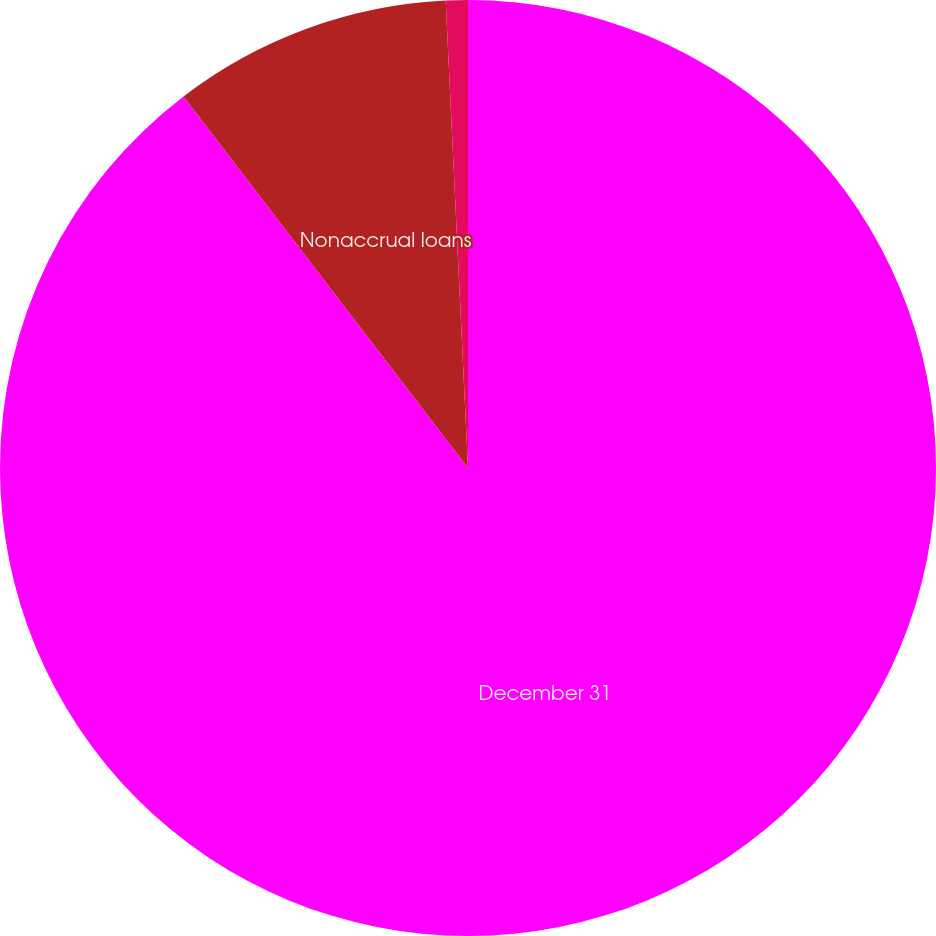Convert chart to OTSL. <chart><loc_0><loc_0><loc_500><loc_500><pie_chart><fcel>December 31<fcel>Nonaccrual loans<fcel>Average nonaccrual loans<nl><fcel>89.6%<fcel>9.64%<fcel>0.76%<nl></chart> 